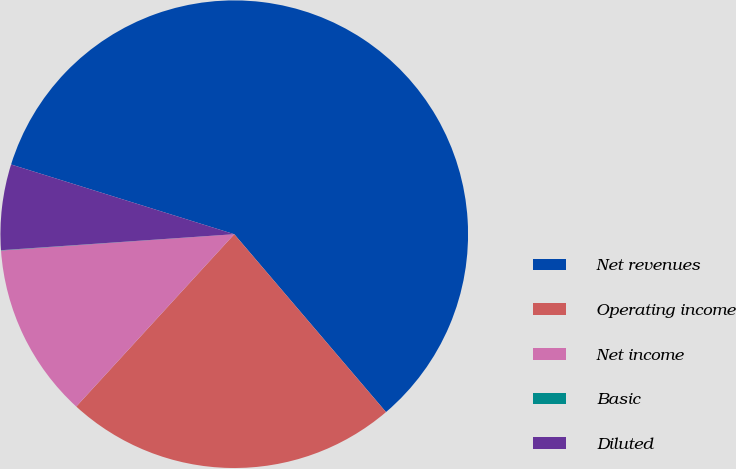<chart> <loc_0><loc_0><loc_500><loc_500><pie_chart><fcel>Net revenues<fcel>Operating income<fcel>Net income<fcel>Basic<fcel>Diluted<nl><fcel>58.94%<fcel>23.05%<fcel>12.08%<fcel>0.02%<fcel>5.91%<nl></chart> 